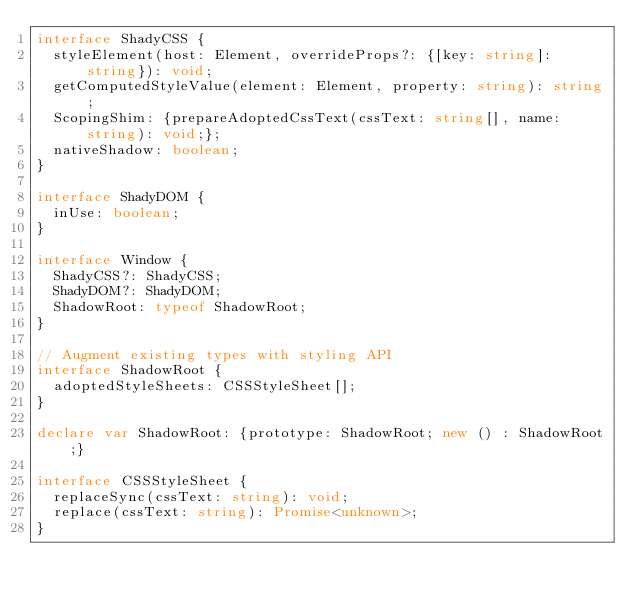<code> <loc_0><loc_0><loc_500><loc_500><_TypeScript_>interface ShadyCSS {
  styleElement(host: Element, overrideProps?: {[key: string]: string}): void;
  getComputedStyleValue(element: Element, property: string): string;
  ScopingShim: {prepareAdoptedCssText(cssText: string[], name: string): void;};
  nativeShadow: boolean;
}

interface ShadyDOM {
  inUse: boolean;
}

interface Window {
  ShadyCSS?: ShadyCSS;
  ShadyDOM?: ShadyDOM;
  ShadowRoot: typeof ShadowRoot;
}

// Augment existing types with styling API
interface ShadowRoot {
  adoptedStyleSheets: CSSStyleSheet[];
}

declare var ShadowRoot: {prototype: ShadowRoot; new () : ShadowRoot;}

interface CSSStyleSheet {
  replaceSync(cssText: string): void;
  replace(cssText: string): Promise<unknown>;
}
</code> 